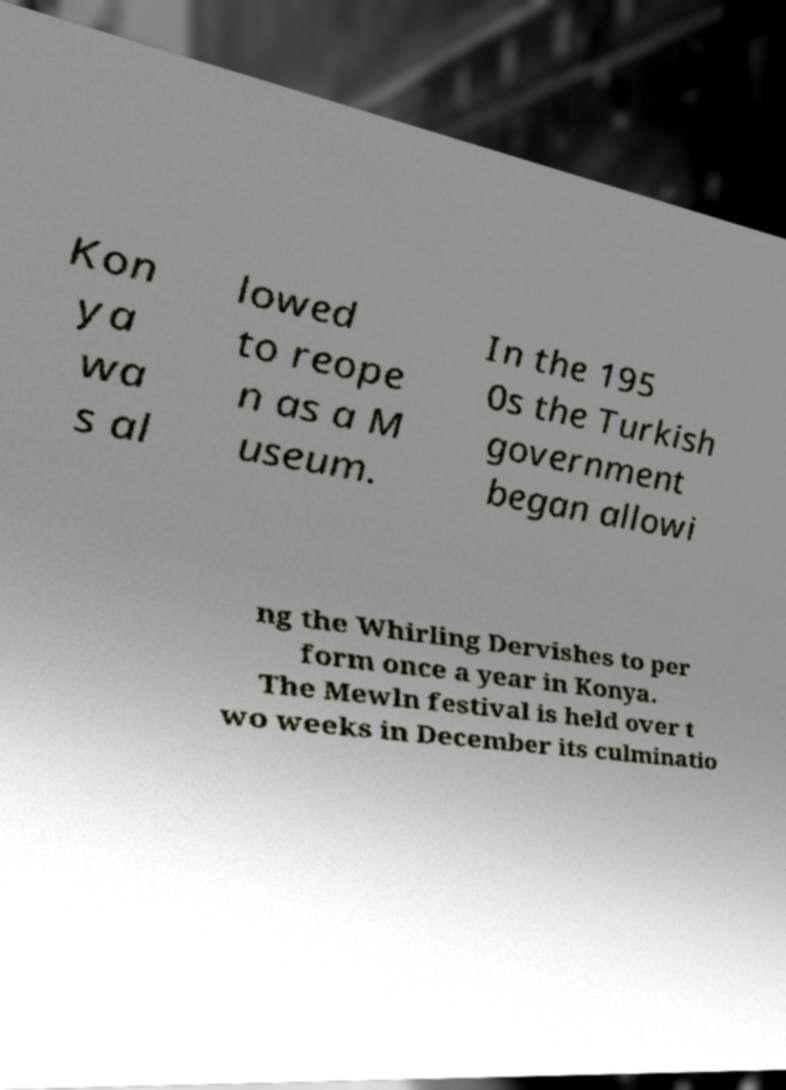I need the written content from this picture converted into text. Can you do that? Kon ya wa s al lowed to reope n as a M useum. In the 195 0s the Turkish government began allowi ng the Whirling Dervishes to per form once a year in Konya. The Mewln festival is held over t wo weeks in December its culminatio 